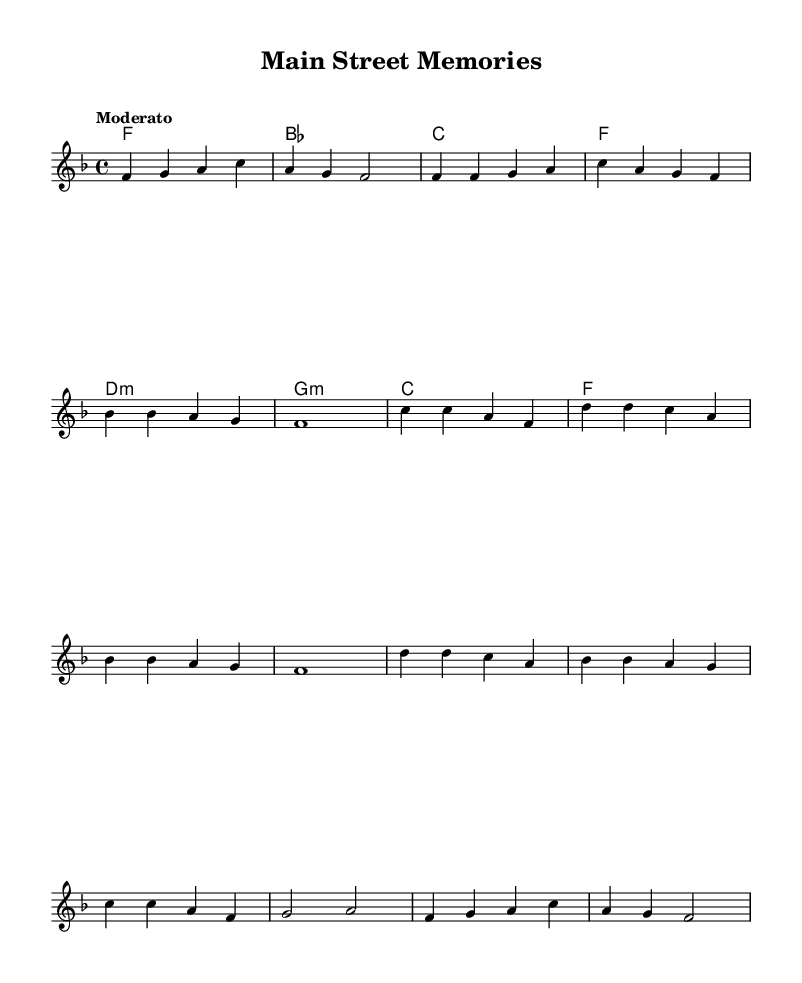What is the key signature of this music? The key signature is F major, which has one flat (B flat). This can be identified by looking at the key signature placed at the beginning of the staff.
Answer: F major What is the time signature of this music? The time signature is 4/4, which indicates four beats per measure. This is typically indicated right after the key signature.
Answer: 4/4 What is the tempo marking of this piece? The tempo marking is Moderato, which is usually placed above the staff to indicate the speed at which the piece should be played.
Answer: Moderato What is the first note of the melody? The first note of the melody is F. This can be seen as the opening note in the melody section of the sheet music.
Answer: F How many measures are in the chorus? There are four measures in the chorus, evident from counting the measures in the chorus section of the music.
Answer: 4 What type of chords are featured in the harmony section? The harmonies feature major and minor chords. This is determined by looking at the chord symbols written in the harmony section, with a mix of major (C, F) and minor (D minor, G minor) chords.
Answer: Major and minor What is the last note of the outro? The last note of the outro is F. This can be identified by checking the final measure of the melody where it resolves back to the starting note.
Answer: F 